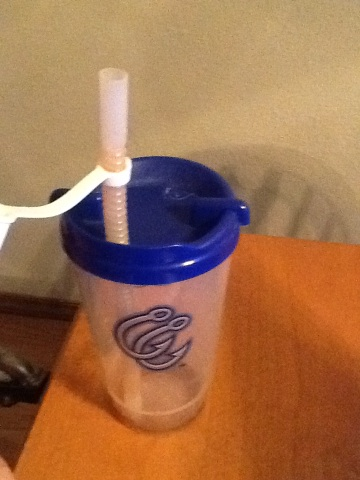What color is the top? The question seems to have been misunderstood as it refers to a top, yet the image shows a clear plastic mug with a blue lid. The lid's color is blue. 